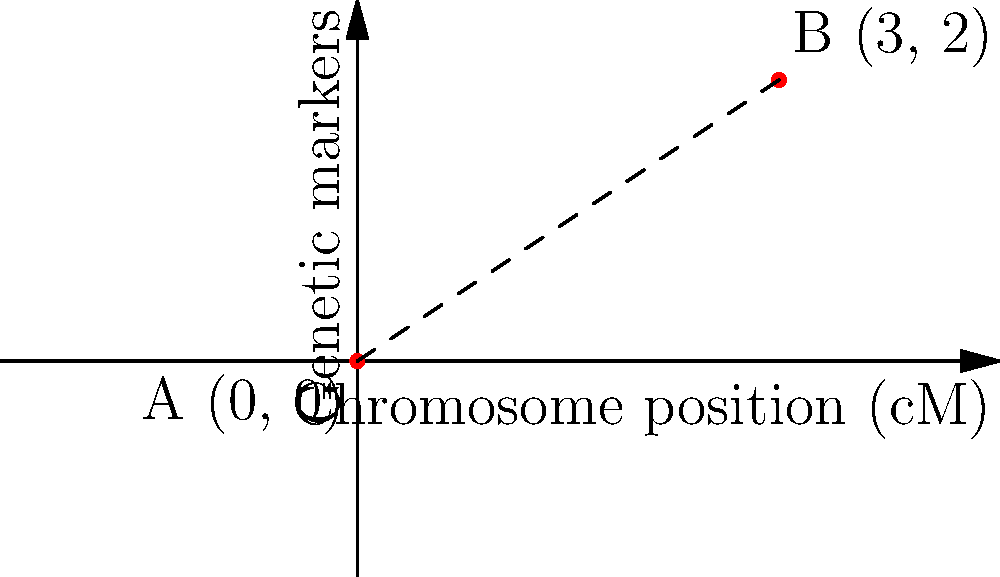In a chromosome mapping study, two genetic markers A and B are positioned on a coordinate system where the x-axis represents the chromosome position in centimorgans (cM) and the y-axis represents the relative position of genetic markers. Marker A is located at (0, 0) and marker B is at (3, 2). Calculate the distance between these two genetic markers on the chromosome map. To calculate the distance between two points on a coordinate plane, we can use the distance formula derived from the Pythagorean theorem:

$$d = \sqrt{(x_2 - x_1)^2 + (y_2 - y_1)^2}$$

Where $(x_1, y_1)$ are the coordinates of the first point and $(x_2, y_2)$ are the coordinates of the second point.

Given:
- Marker A: $(x_1, y_1) = (0, 0)$
- Marker B: $(x_2, y_2) = (3, 2)$

Let's substitute these values into the formula:

$$\begin{align}
d &= \sqrt{(x_2 - x_1)^2 + (y_2 - y_1)^2} \\
&= \sqrt{(3 - 0)^2 + (2 - 0)^2} \\
&= \sqrt{3^2 + 2^2} \\
&= \sqrt{9 + 4} \\
&= \sqrt{13} \\
&\approx 3.61 \text{ cM}
\end{align}$$

The distance between the two genetic markers is approximately 3.61 cM.
Answer: $\sqrt{13}$ cM or approximately 3.61 cM 